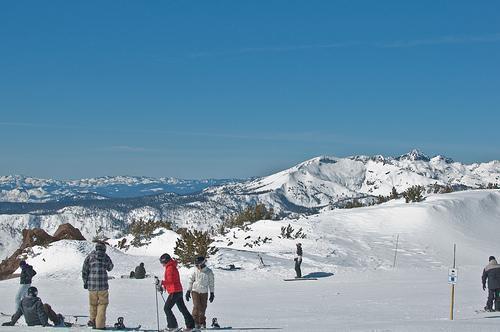How many people are present?
Give a very brief answer. 8. How many skiers are sitting down?
Give a very brief answer. 2. How many chairs are present?
Give a very brief answer. 0. 